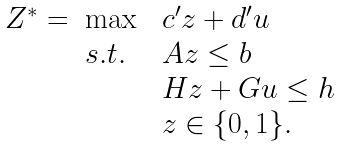<formula> <loc_0><loc_0><loc_500><loc_500>\begin{array} { l l l l } Z ^ { * } = & \max \ & c ^ { \prime } z + d ^ { \prime } u & \\ & s . t . \ & A z \leq b & \\ & & H z + G u \leq h & \\ & & z \in \{ 0 , 1 \} . \end{array}</formula> 